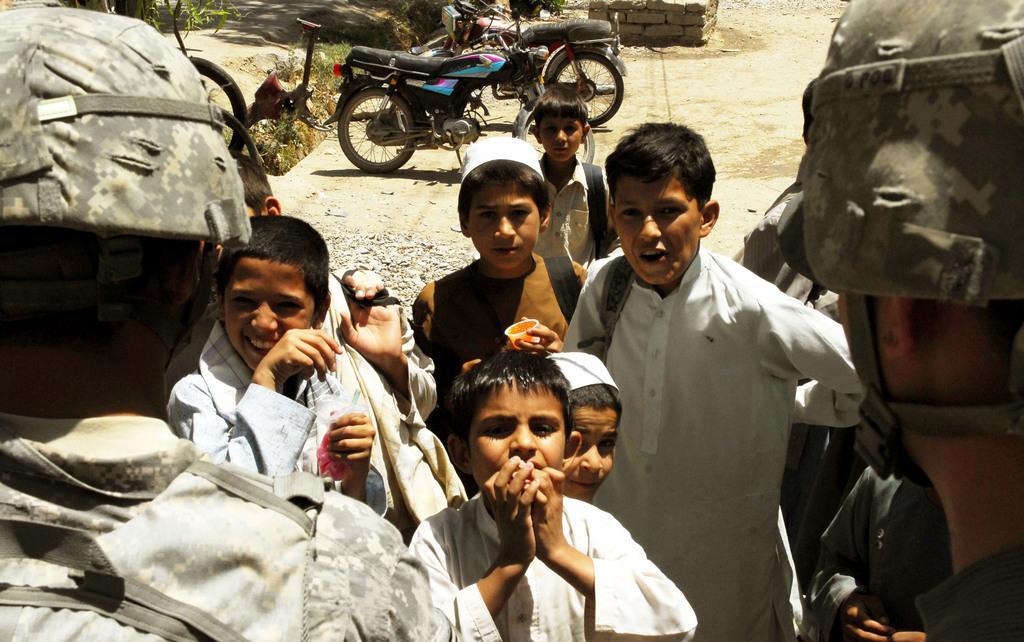Describe this image in one or two sentences. In this image there is a group of persons standing as we can see in the middle of this image. There are two bikes on the top of this image, and there are some leaves of trees on the top left corner of this image. 